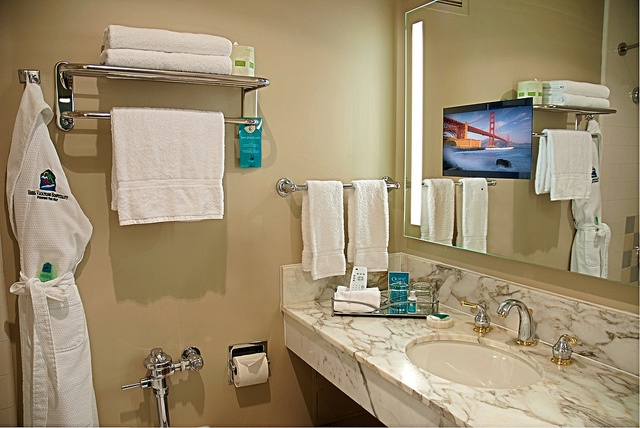Describe the objects in this image and their specific colors. I can see tv in black, gray, and darkgray tones, sink in black and tan tones, bottle in black, gray, olive, and darkgray tones, remote in black, lightgray, darkgray, and gray tones, and bottle in black, teal, darkgray, and beige tones in this image. 